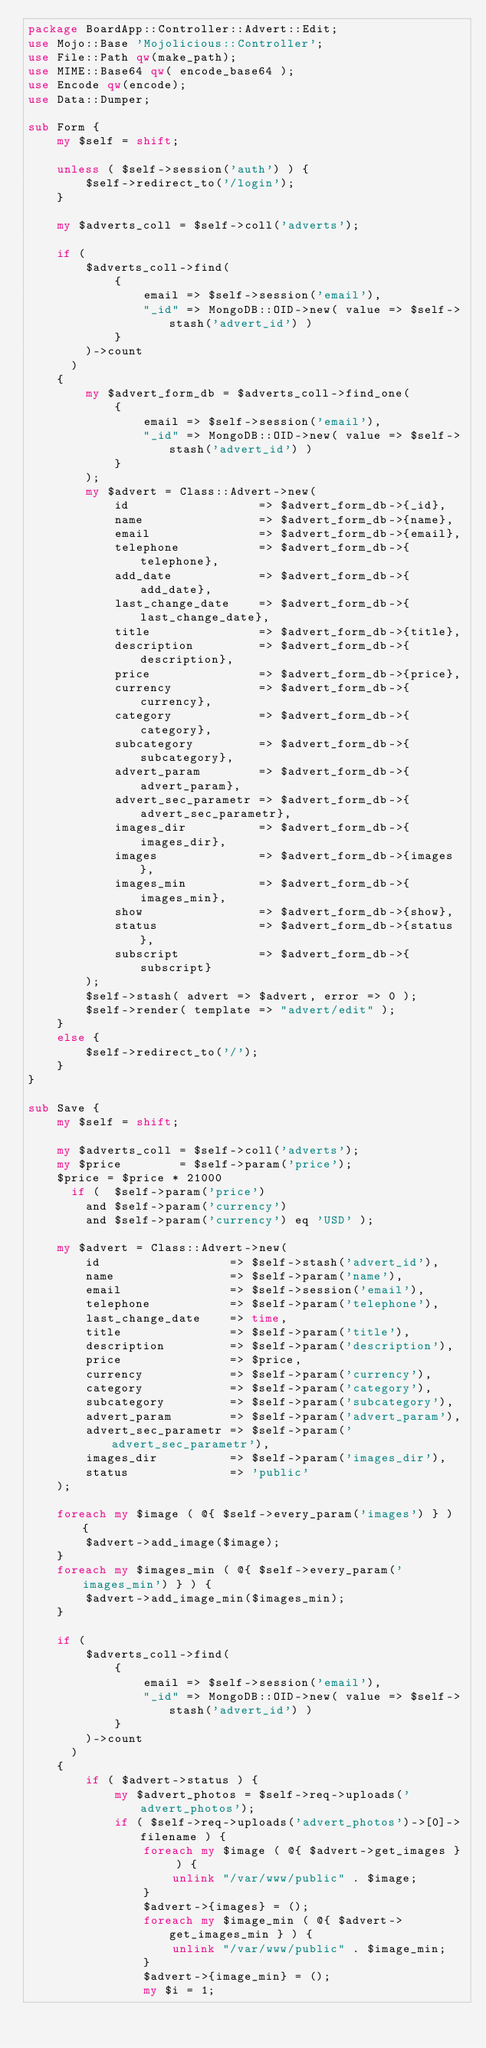<code> <loc_0><loc_0><loc_500><loc_500><_Perl_>package BoardApp::Controller::Advert::Edit;
use Mojo::Base 'Mojolicious::Controller';
use File::Path qw(make_path);
use MIME::Base64 qw( encode_base64 );
use Encode qw(encode);
use Data::Dumper;

sub Form {
    my $self = shift;

    unless ( $self->session('auth') ) {
        $self->redirect_to('/login');
    }

    my $adverts_coll = $self->coll('adverts');

    if (
        $adverts_coll->find(
            {
                email => $self->session('email'),
                "_id" => MongoDB::OID->new( value => $self->stash('advert_id') )
            }
        )->count
      )
    {
        my $advert_form_db = $adverts_coll->find_one(
            {
                email => $self->session('email'),
                "_id" => MongoDB::OID->new( value => $self->stash('advert_id') )
            }
        );
        my $advert = Class::Advert->new(
            id                  => $advert_form_db->{_id},
            name                => $advert_form_db->{name},
            email               => $advert_form_db->{email},
            telephone           => $advert_form_db->{telephone},
            add_date            => $advert_form_db->{add_date},
            last_change_date    => $advert_form_db->{last_change_date},
            title               => $advert_form_db->{title},
            description         => $advert_form_db->{description},
            price               => $advert_form_db->{price},
            currency            => $advert_form_db->{currency},
            category            => $advert_form_db->{category},
            subcategory         => $advert_form_db->{subcategory},
            advert_param        => $advert_form_db->{advert_param},
            advert_sec_parametr => $advert_form_db->{advert_sec_parametr},
            images_dir          => $advert_form_db->{images_dir},
            images              => $advert_form_db->{images},
            images_min          => $advert_form_db->{images_min},
            show                => $advert_form_db->{show},
            status              => $advert_form_db->{status},
            subscript           => $advert_form_db->{subscript}
        );
        $self->stash( advert => $advert, error => 0 );
        $self->render( template => "advert/edit" );
    }
    else {
        $self->redirect_to('/');
    }
}

sub Save {
    my $self = shift;

    my $adverts_coll = $self->coll('adverts');
    my $price        = $self->param('price');
    $price = $price * 21000
      if (  $self->param('price')
        and $self->param('currency')
        and $self->param('currency') eq 'USD' );

    my $advert = Class::Advert->new(
        id                  => $self->stash('advert_id'),
        name                => $self->param('name'),
        email               => $self->session('email'),
        telephone           => $self->param('telephone'),
        last_change_date    => time,
        title               => $self->param('title'),
        description         => $self->param('description'),
        price               => $price,
        currency            => $self->param('currency'),
        category            => $self->param('category'),
        subcategory         => $self->param('subcategory'),
        advert_param        => $self->param('advert_param'),
        advert_sec_parametr => $self->param('advert_sec_parametr'),
        images_dir          => $self->param('images_dir'),
        status              => 'public'
    );

    foreach my $image ( @{ $self->every_param('images') } ) {
        $advert->add_image($image);
    }
    foreach my $images_min ( @{ $self->every_param('images_min') } ) {
        $advert->add_image_min($images_min);
    }

    if (
        $adverts_coll->find(
            {
                email => $self->session('email'),
                "_id" => MongoDB::OID->new( value => $self->stash('advert_id') )
            }
        )->count
      )
    {
        if ( $advert->status ) {
            my $advert_photos = $self->req->uploads('advert_photos');
            if ( $self->req->uploads('advert_photos')->[0]->filename ) {
                foreach my $image ( @{ $advert->get_images } ) {
                    unlink "/var/www/public" . $image;
                }
                $advert->{images} = ();
                foreach my $image_min ( @{ $advert->get_images_min } ) {
                    unlink "/var/www/public" . $image_min;
                }
                $advert->{image_min} = ();
                my $i = 1;</code> 